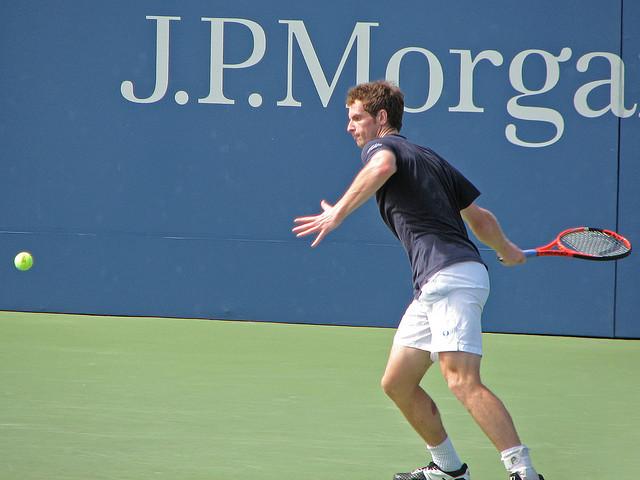Is this match sponsored by J.P. Morgan?
Give a very brief answer. Yes. Is the ball in play?
Concise answer only. Yes. What color shorts is he wearing?
Quick response, please. White. 